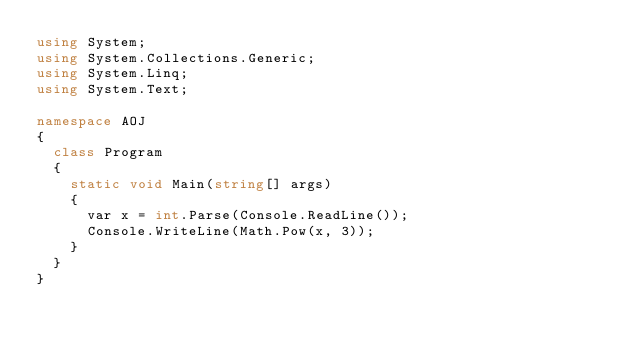Convert code to text. <code><loc_0><loc_0><loc_500><loc_500><_C#_>using System;
using System.Collections.Generic;
using System.Linq;
using System.Text;

namespace AOJ
{
	class Program
	{
		static void Main(string[] args)
		{
			var x = int.Parse(Console.ReadLine());
			Console.WriteLine(Math.Pow(x, 3));
		}
	}
}</code> 